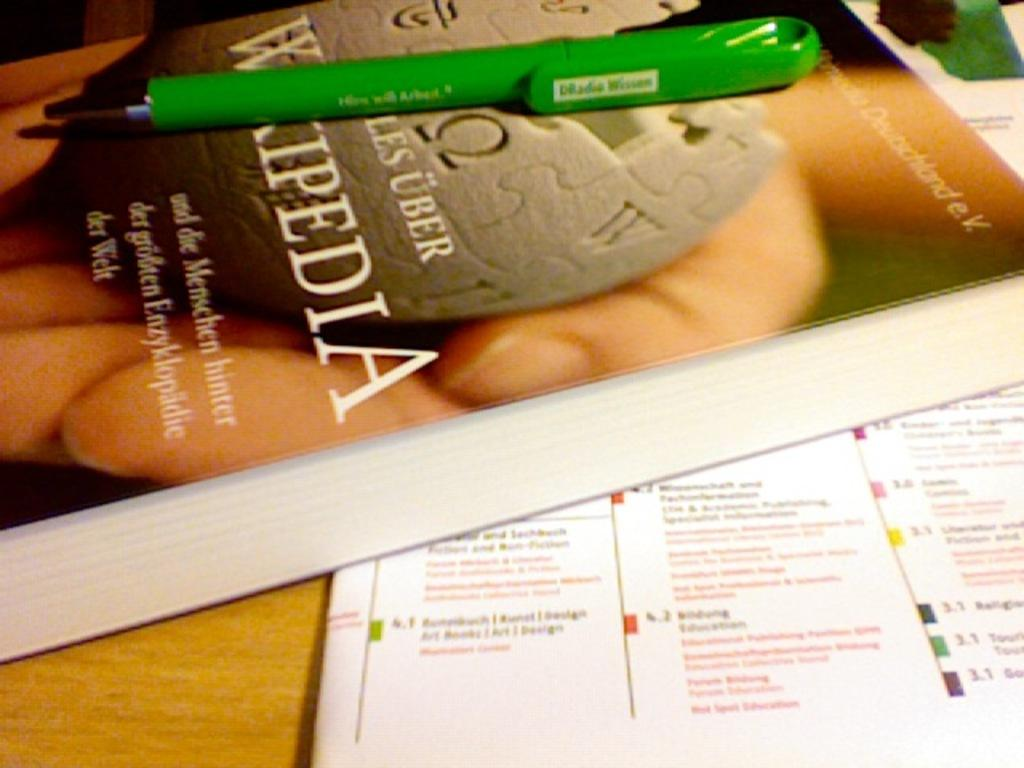Provide a one-sentence caption for the provided image. A book that says Wikipedia has a green pen on it. 